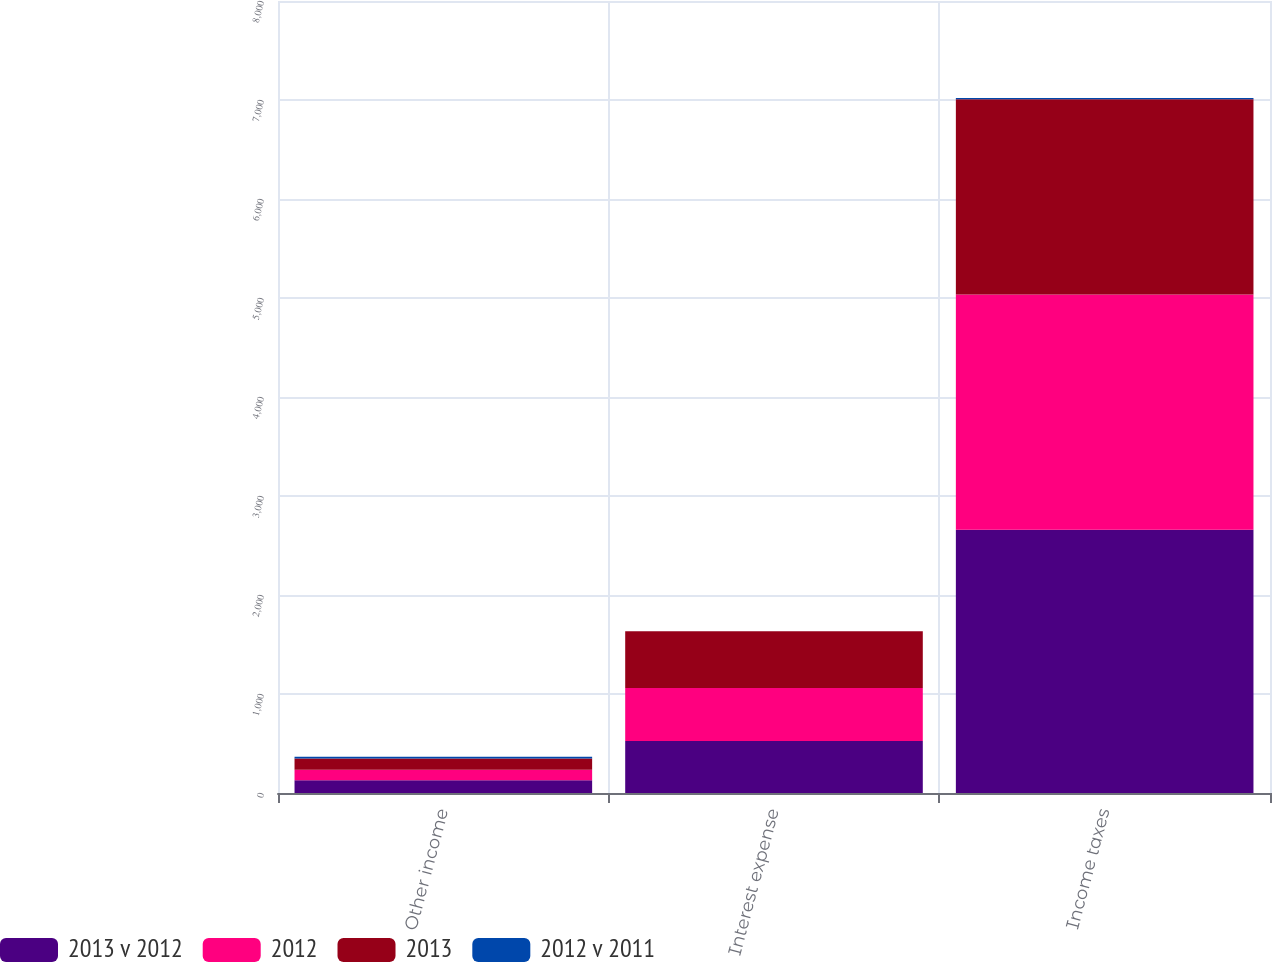Convert chart. <chart><loc_0><loc_0><loc_500><loc_500><stacked_bar_chart><ecel><fcel>Other income<fcel>Interest expense<fcel>Income taxes<nl><fcel>2013 v 2012<fcel>128<fcel>526<fcel>2660<nl><fcel>2012<fcel>108<fcel>535<fcel>2375<nl><fcel>2013<fcel>112<fcel>572<fcel>1972<nl><fcel>2012 v 2011<fcel>19<fcel>2<fcel>12<nl></chart> 